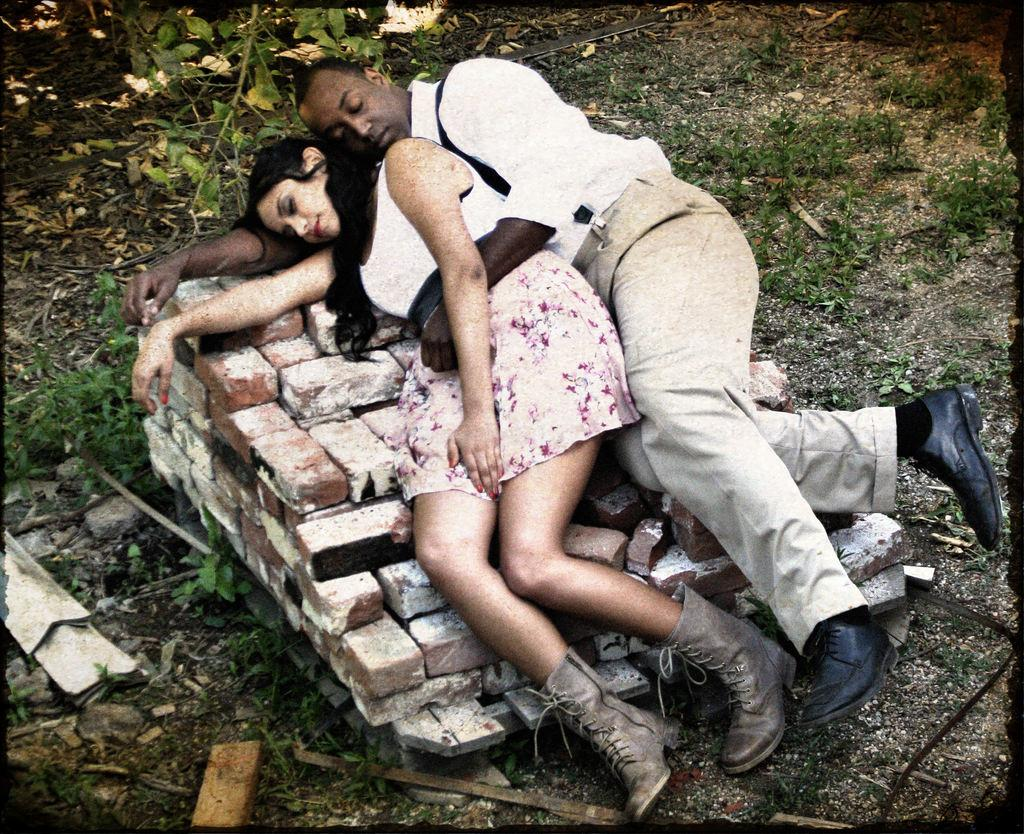Who are the people in the image? There is a man and a woman in the image. What are the man and woman doing in the image? Both the man and woman are lying on bricks. What can be seen on the ground in the image? Dried leaves and grass are visible on the ground. What is the color of the borders in the image? The image has black borders. What type of health advice is the man giving to the woman in the image? There is no indication in the image that the man is giving any health advice to the woman. Can you tell me how many examples of swimming can be seen in the image? There are no examples of swimming present in the image. 